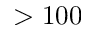Convert formula to latex. <formula><loc_0><loc_0><loc_500><loc_500>> 1 0 0</formula> 